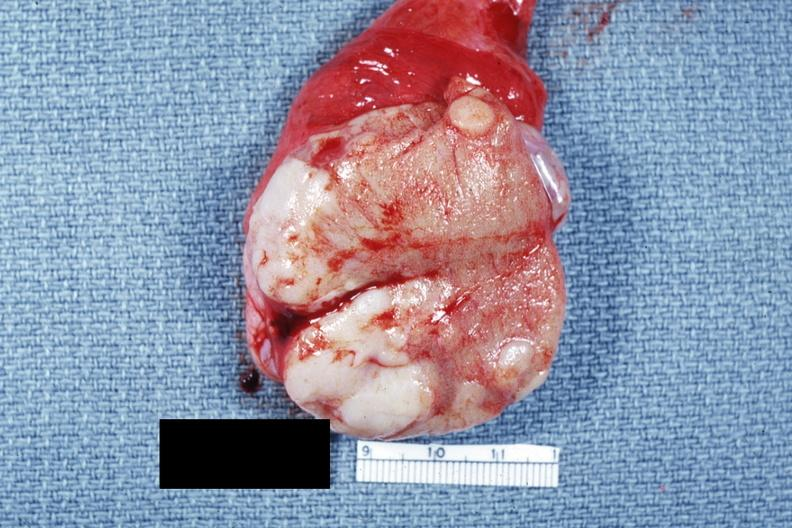what said to be adenocarcinoma?
Answer the question using a single word or phrase. Close-up tumor well shown primary not stated 